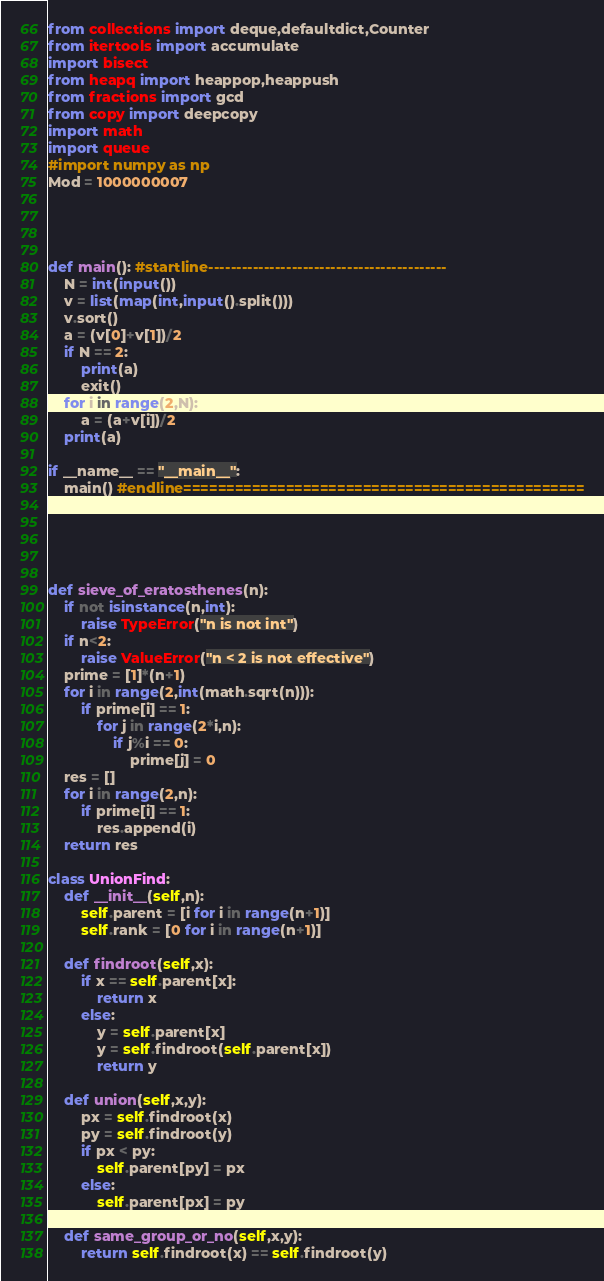<code> <loc_0><loc_0><loc_500><loc_500><_Python_>from collections import deque,defaultdict,Counter
from itertools import accumulate
import bisect
from heapq import heappop,heappush
from fractions import gcd
from copy import deepcopy
import math
import queue
#import numpy as np
Mod = 1000000007




def main(): #startline-------------------------------------------
    N = int(input())
    v = list(map(int,input().split()))
    v.sort()
    a = (v[0]+v[1])/2
    if N == 2:
        print(a)
        exit()
    for i in range(2,N):
        a = (a+v[i])/2
    print(a)

if __name__ == "__main__":
    main() #endline===============================================





def sieve_of_eratosthenes(n):
    if not isinstance(n,int):
        raise TypeError("n is not int")
    if n<2:
        raise ValueError("n < 2 is not effective")
    prime = [1]*(n+1)
    for i in range(2,int(math.sqrt(n))):
        if prime[i] == 1:
            for j in range(2*i,n):
                if j%i == 0:
                    prime[j] = 0
    res = []
    for i in range(2,n):
        if prime[i] == 1:
            res.append(i)
    return res

class UnionFind:
    def __init__(self,n):
        self.parent = [i for i in range(n+1)]
        self.rank = [0 for i in range(n+1)]
    
    def findroot(self,x):
        if x == self.parent[x]:
            return x
        else:
            y = self.parent[x]
            y = self.findroot(self.parent[x])
            return y
    
    def union(self,x,y):
        px = self.findroot(x)
        py = self.findroot(y)
        if px < py:
            self.parent[py] = px
        else:
            self.parent[px] = py

    def same_group_or_no(self,x,y):
        return self.findroot(x) == self.findroot(y)</code> 